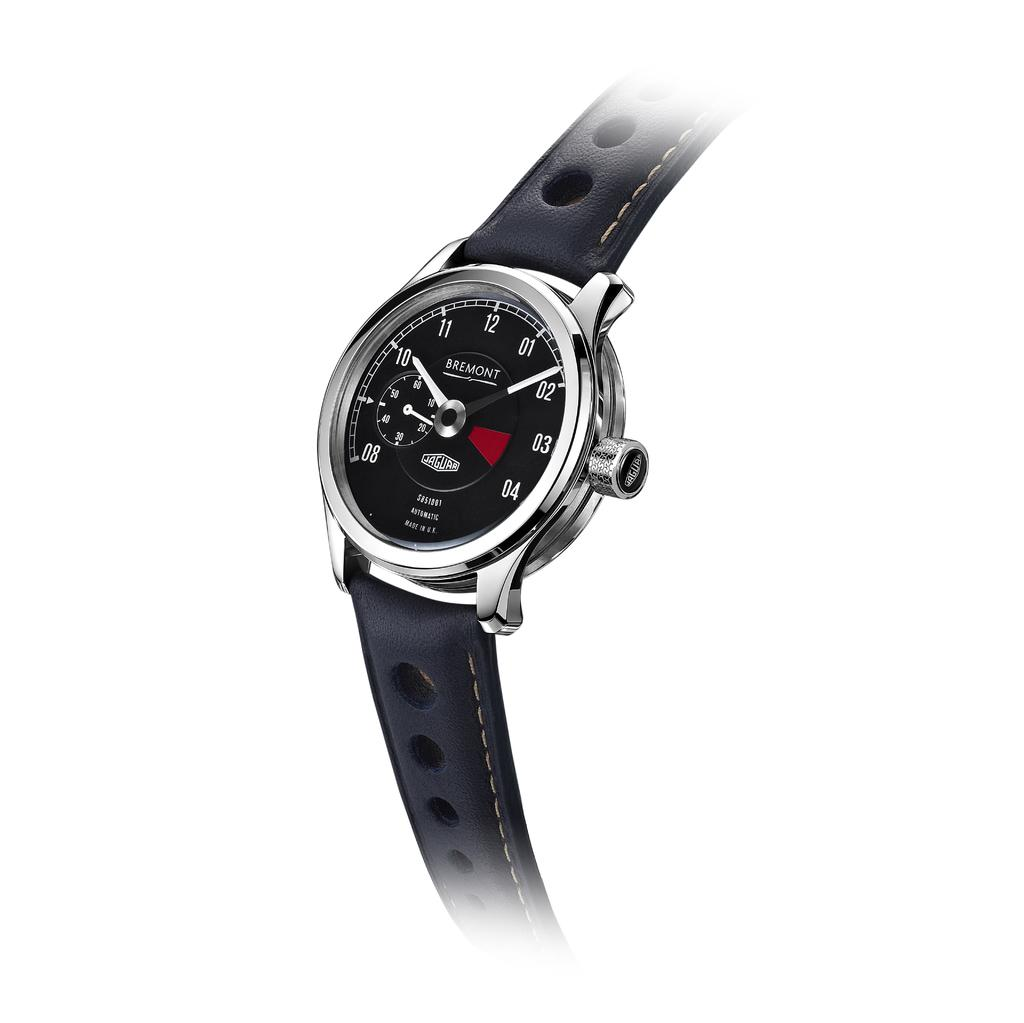<image>
Describe the image concisely. A Bremont watch reads eight minutes after ten. 